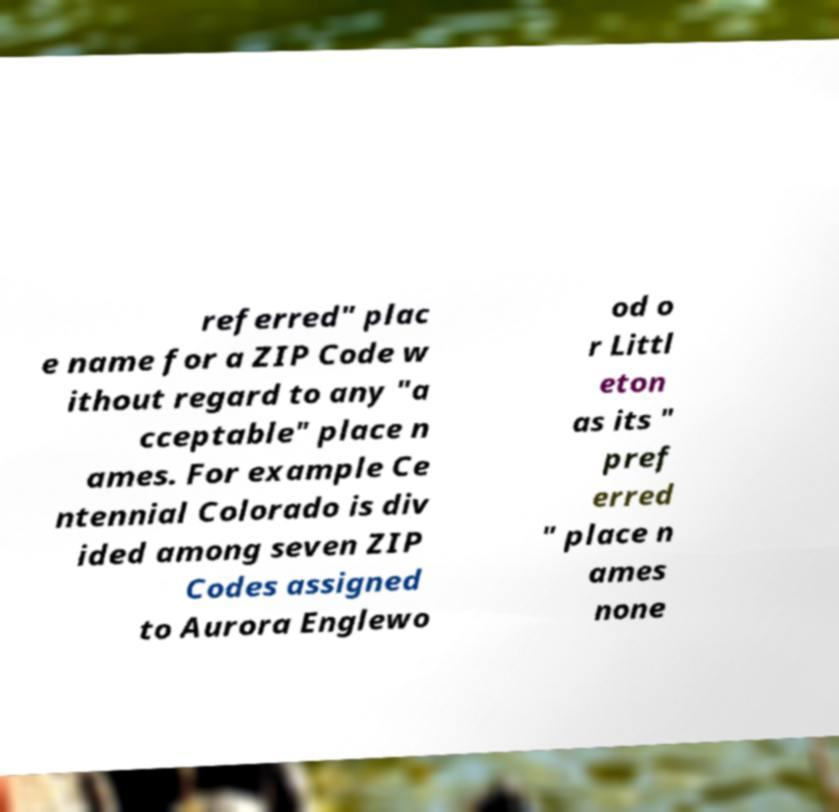Could you extract and type out the text from this image? referred" plac e name for a ZIP Code w ithout regard to any "a cceptable" place n ames. For example Ce ntennial Colorado is div ided among seven ZIP Codes assigned to Aurora Englewo od o r Littl eton as its " pref erred " place n ames none 